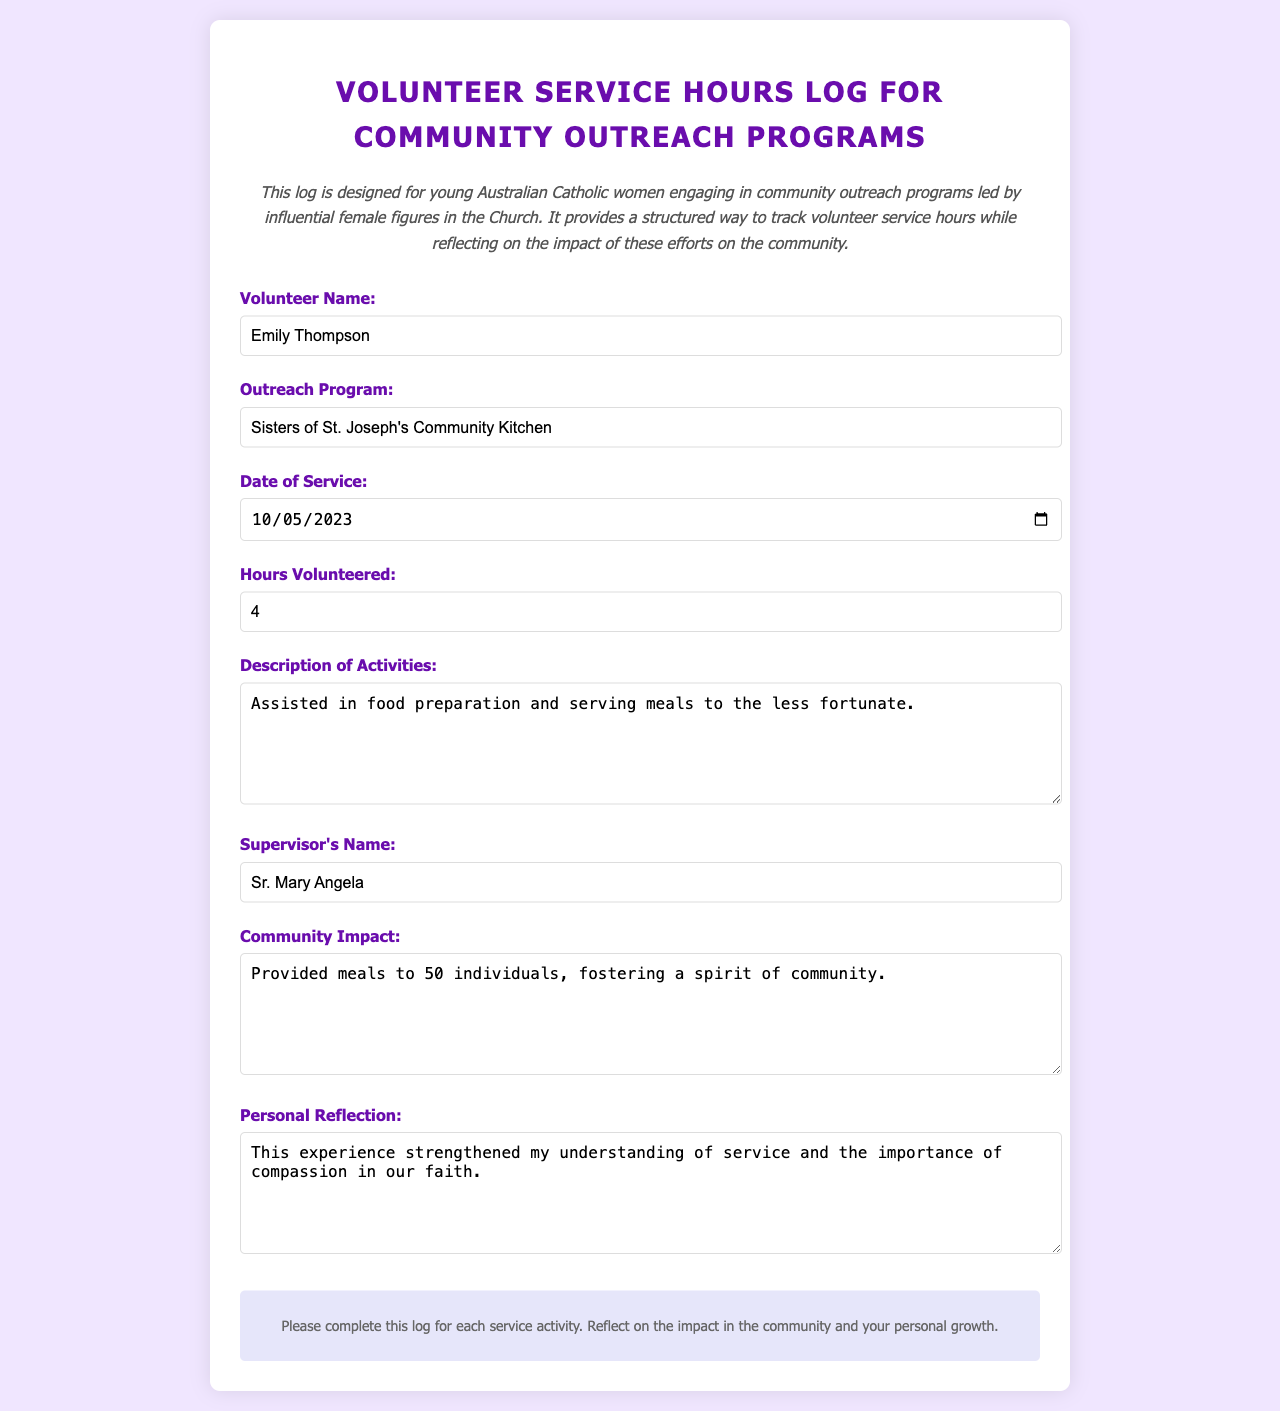What is the name of the volunteer? The volunteer's name is specified in the form field labeled "Volunteer Name."
Answer: Emily Thompson What is the date of service? The date of service is presented in the "Date of Service" field.
Answer: 2023-10-05 How many hours did the volunteer serve? The hours volunteered are indicated in the "Hours Volunteered" field.
Answer: 4 What is the name of the outreach program? The outreach program can be found in the "Outreach Program" section of the form.
Answer: Sisters of St. Joseph's Community Kitchen Who is the supervisor? The supervisor's name is listed under the "Supervisor's Name" field.
Answer: Sr. Mary Angela What was one of the activities performed during the service? The activities performed are described in the "Description of Activities" section.
Answer: Assisted in food preparation and serving meals What is the community impact reported? The community impact is detailed in the "Community Impact" field of the log.
Answer: Provided meals to 50 individuals, fostering a spirit of community What personal reflection did the volunteer share? The personal reflection is included in the "Personal Reflection" section of the form.
Answer: This experience strengthened my understanding of service and the importance of compassion in our faith 